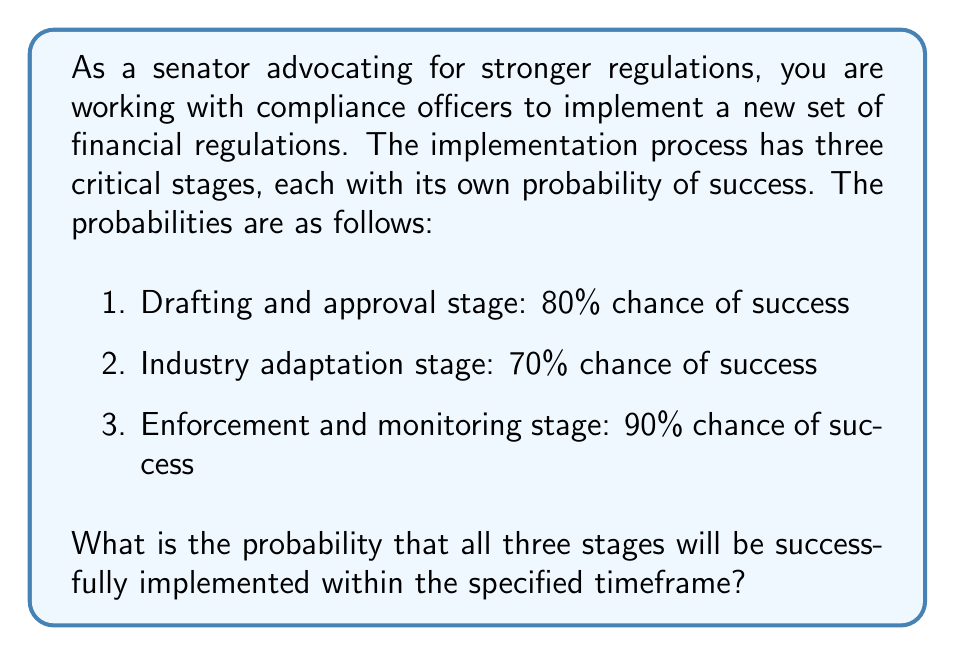Can you solve this math problem? To solve this problem, we need to use the concept of independent events in probability theory. Since each stage must be successful for the overall implementation to be considered successful, we need to calculate the probability of all three events occurring together.

For independent events, the probability of all events occurring is the product of their individual probabilities.

Let's define our events:
$A$: Success in drafting and approval stage
$B$: Success in industry adaptation stage
$C$: Success in enforcement and monitoring stage

Given probabilities:
$P(A) = 0.80$
$P(B) = 0.70$
$P(C) = 0.90$

The probability of all three stages being successful is:

$$P(A \cap B \cap C) = P(A) \times P(B) \times P(C)$$

Substituting the values:

$$P(A \cap B \cap C) = 0.80 \times 0.70 \times 0.90$$

Calculating:

$$P(A \cap B \cap C) = 0.504$$

To convert to a percentage, we multiply by 100:

$$0.504 \times 100 = 50.4\%$$
Answer: The probability that all three stages of the new financial regulations will be successfully implemented within the specified timeframe is 50.4%. 